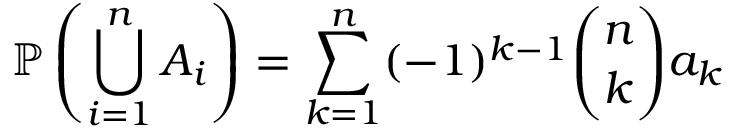<formula> <loc_0><loc_0><loc_500><loc_500>\mathbb { P } \left ( \bigcup _ { i = 1 } ^ { n } A _ { i } \right ) = \sum _ { k = 1 } ^ { n } ( - 1 ) ^ { k - 1 } { \binom { n } { k } } a _ { k }</formula> 